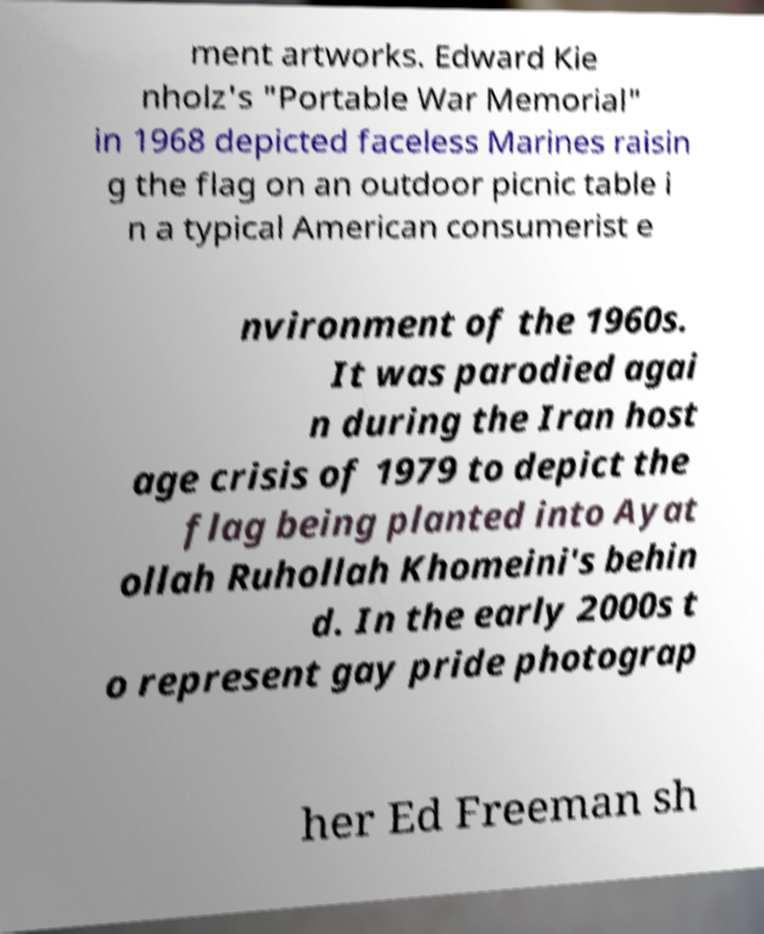I need the written content from this picture converted into text. Can you do that? ment artworks. Edward Kie nholz's "Portable War Memorial" in 1968 depicted faceless Marines raisin g the flag on an outdoor picnic table i n a typical American consumerist e nvironment of the 1960s. It was parodied agai n during the Iran host age crisis of 1979 to depict the flag being planted into Ayat ollah Ruhollah Khomeini's behin d. In the early 2000s t o represent gay pride photograp her Ed Freeman sh 